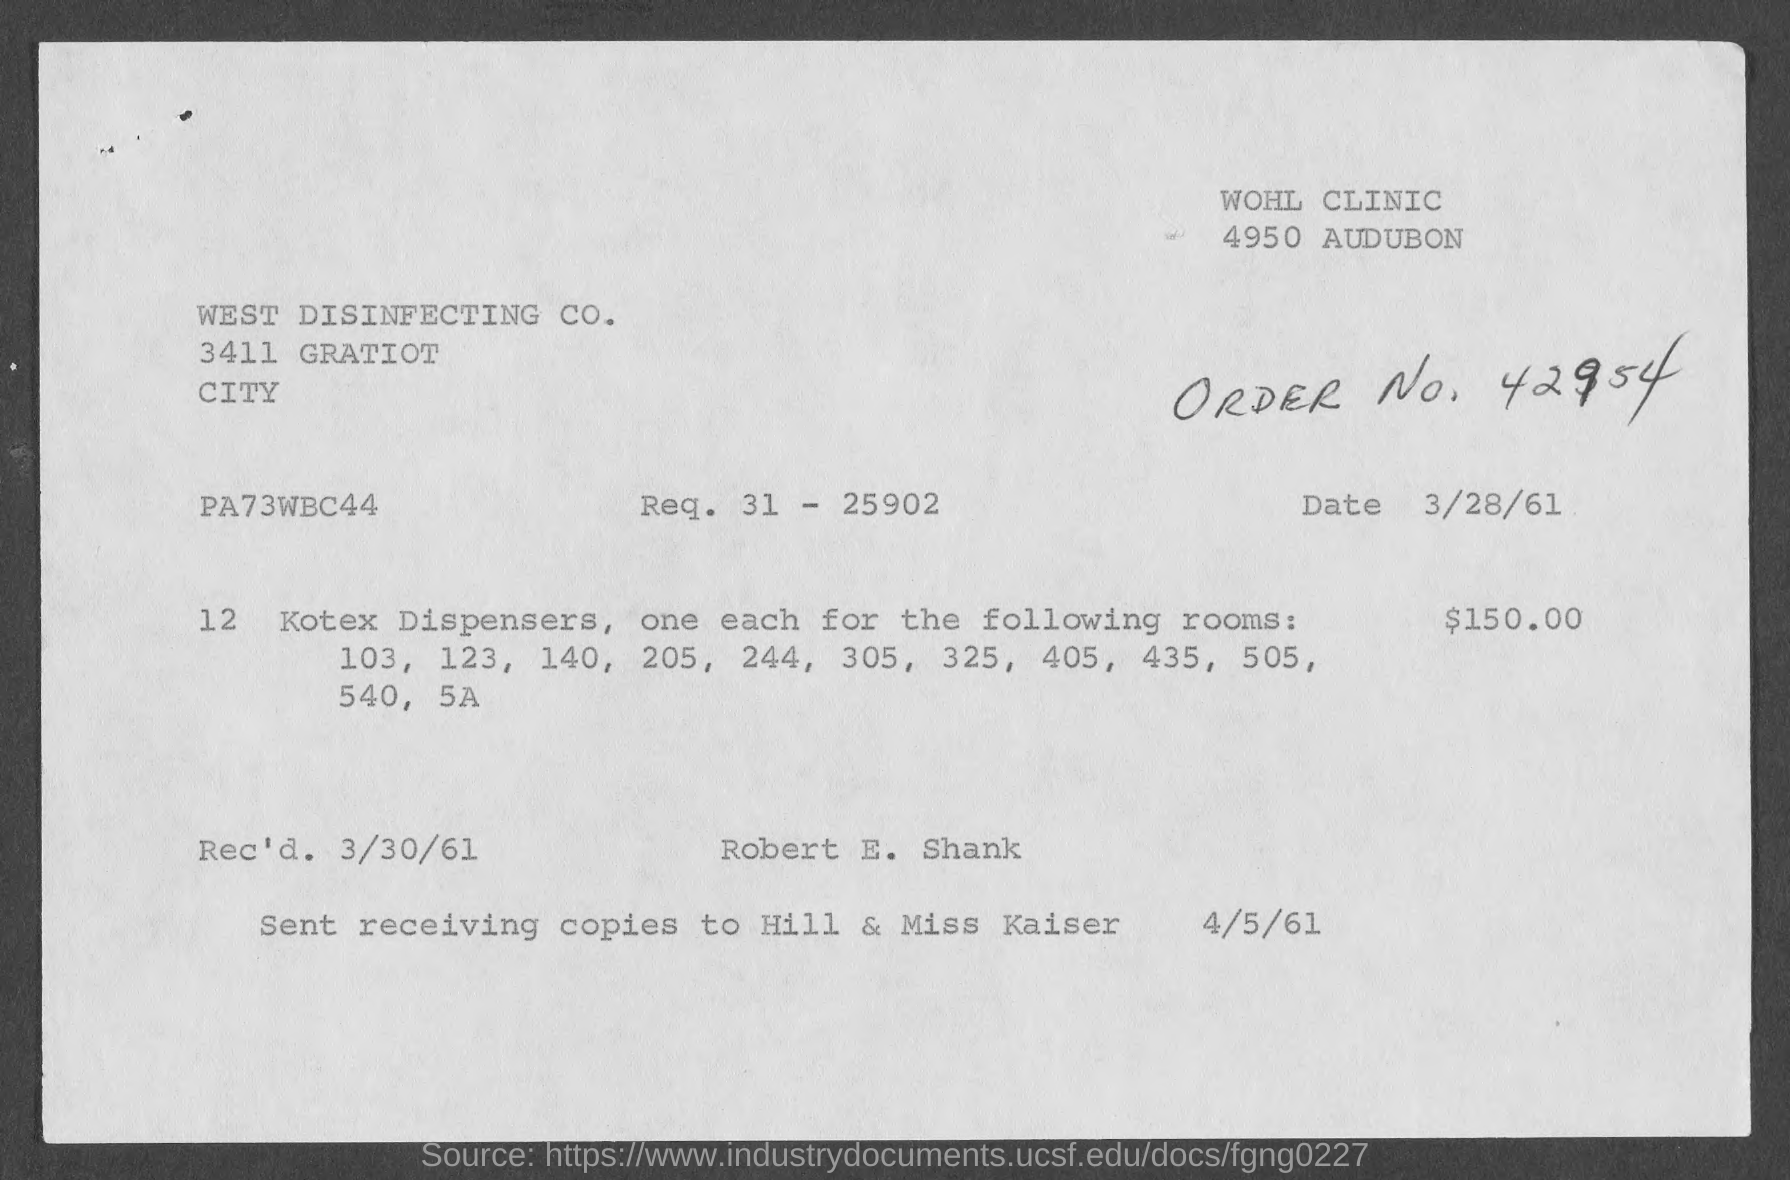What is the received date of this document?
Offer a very short reply. 3/30/61. What is the Req. no given in the document?
Offer a terse response. 31- 25902. What is the amount mentioned for Kotex Dispensers in the document?
Give a very brief answer. 150.00. 